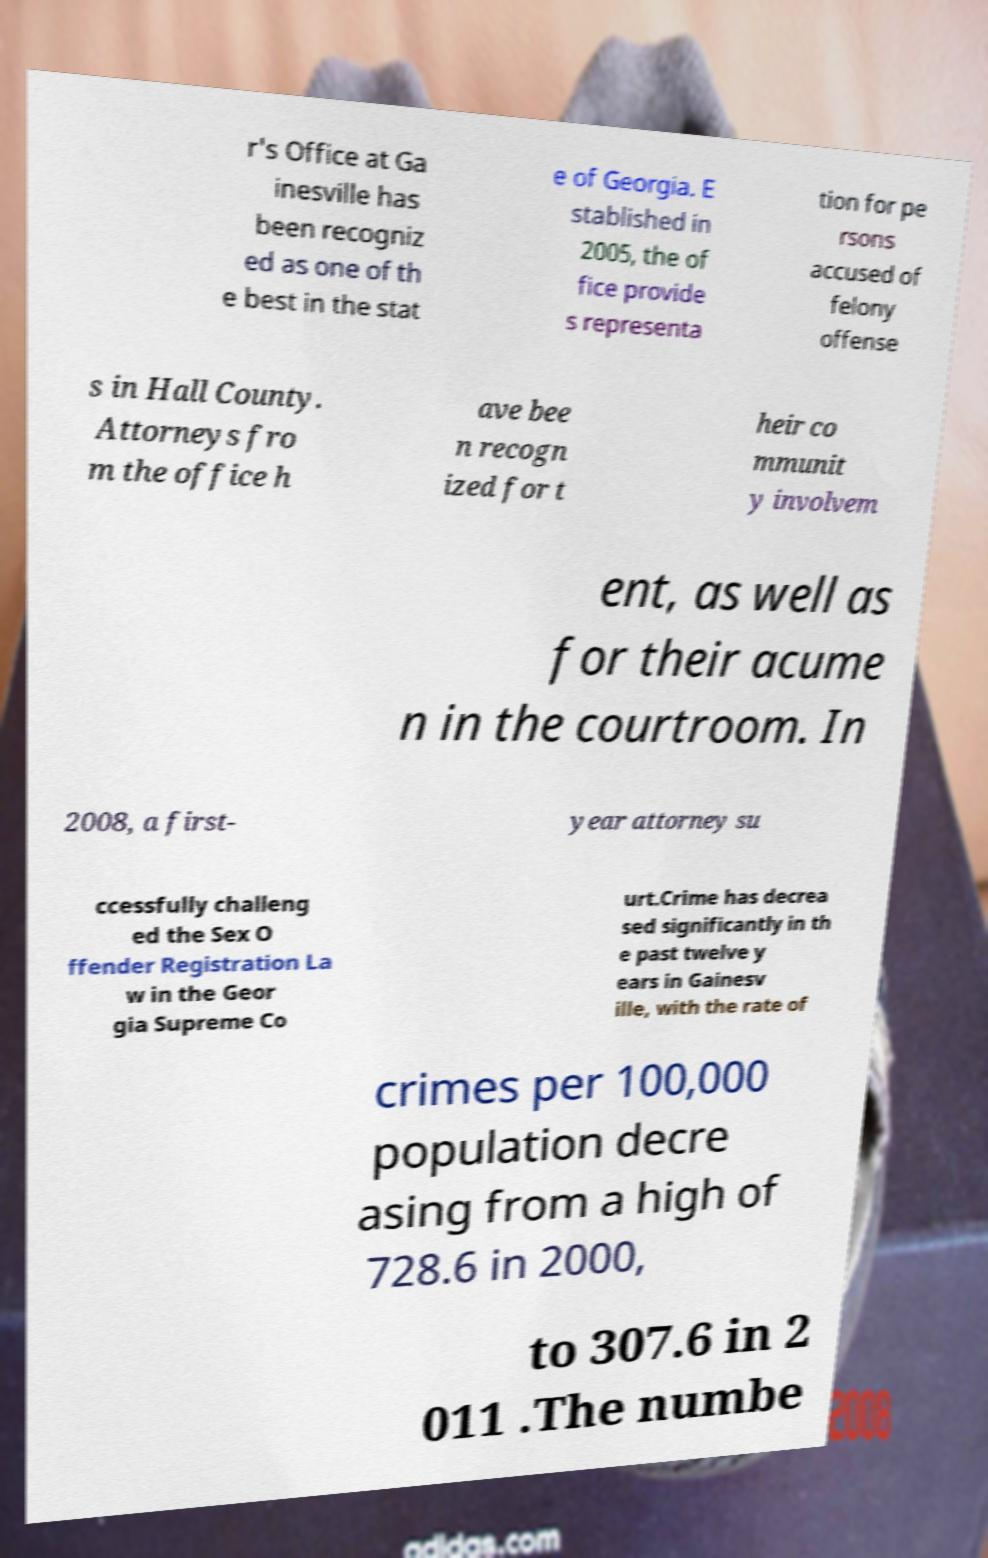There's text embedded in this image that I need extracted. Can you transcribe it verbatim? r's Office at Ga inesville has been recogniz ed as one of th e best in the stat e of Georgia. E stablished in 2005, the of fice provide s representa tion for pe rsons accused of felony offense s in Hall County. Attorneys fro m the office h ave bee n recogn ized for t heir co mmunit y involvem ent, as well as for their acume n in the courtroom. In 2008, a first- year attorney su ccessfully challeng ed the Sex O ffender Registration La w in the Geor gia Supreme Co urt.Crime has decrea sed significantly in th e past twelve y ears in Gainesv ille, with the rate of crimes per 100,000 population decre asing from a high of 728.6 in 2000, to 307.6 in 2 011 .The numbe 